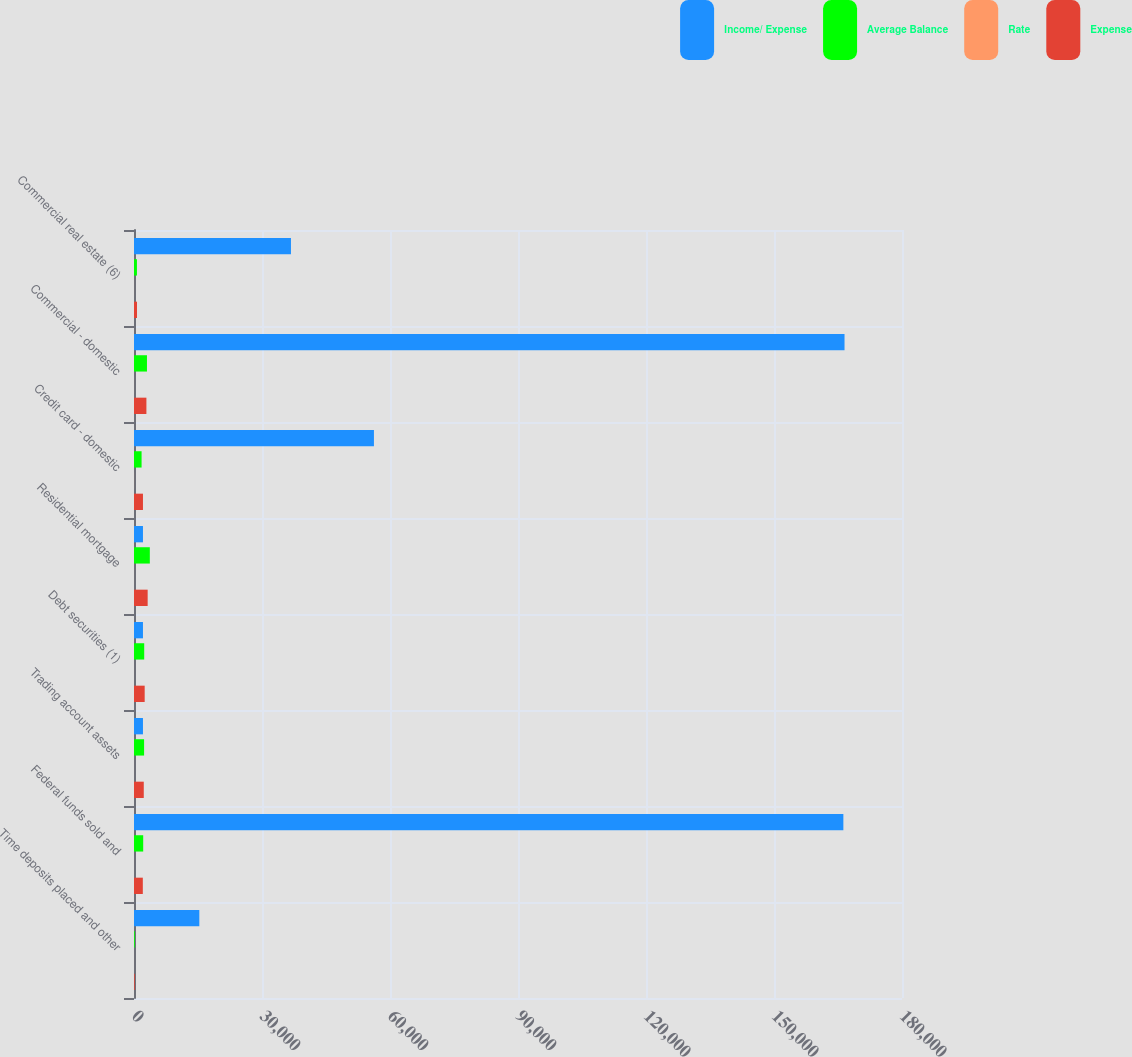<chart> <loc_0><loc_0><loc_500><loc_500><stacked_bar_chart><ecel><fcel>Time deposits placed and other<fcel>Federal funds sold and<fcel>Trading account assets<fcel>Debt securities (1)<fcel>Residential mortgage<fcel>Credit card - domestic<fcel>Commercial - domestic<fcel>Commercial real estate (6)<nl><fcel>Income/ Expense<fcel>15310<fcel>166258<fcel>2101<fcel>2101<fcel>2101<fcel>56235<fcel>166529<fcel>36788<nl><fcel>Average Balance<fcel>188<fcel>2156<fcel>2364<fcel>2394<fcel>3708<fcel>1777<fcel>3039<fcel>687<nl><fcel>Rate<fcel>4.92<fcel>5.19<fcel>5.03<fcel>5.39<fcel>5.7<fcel>12.67<fcel>7.32<fcel>7.49<nl><fcel>Expense<fcel>166<fcel>2068<fcel>2289<fcel>2504<fcel>3202<fcel>2101<fcel>2907<fcel>704<nl></chart> 